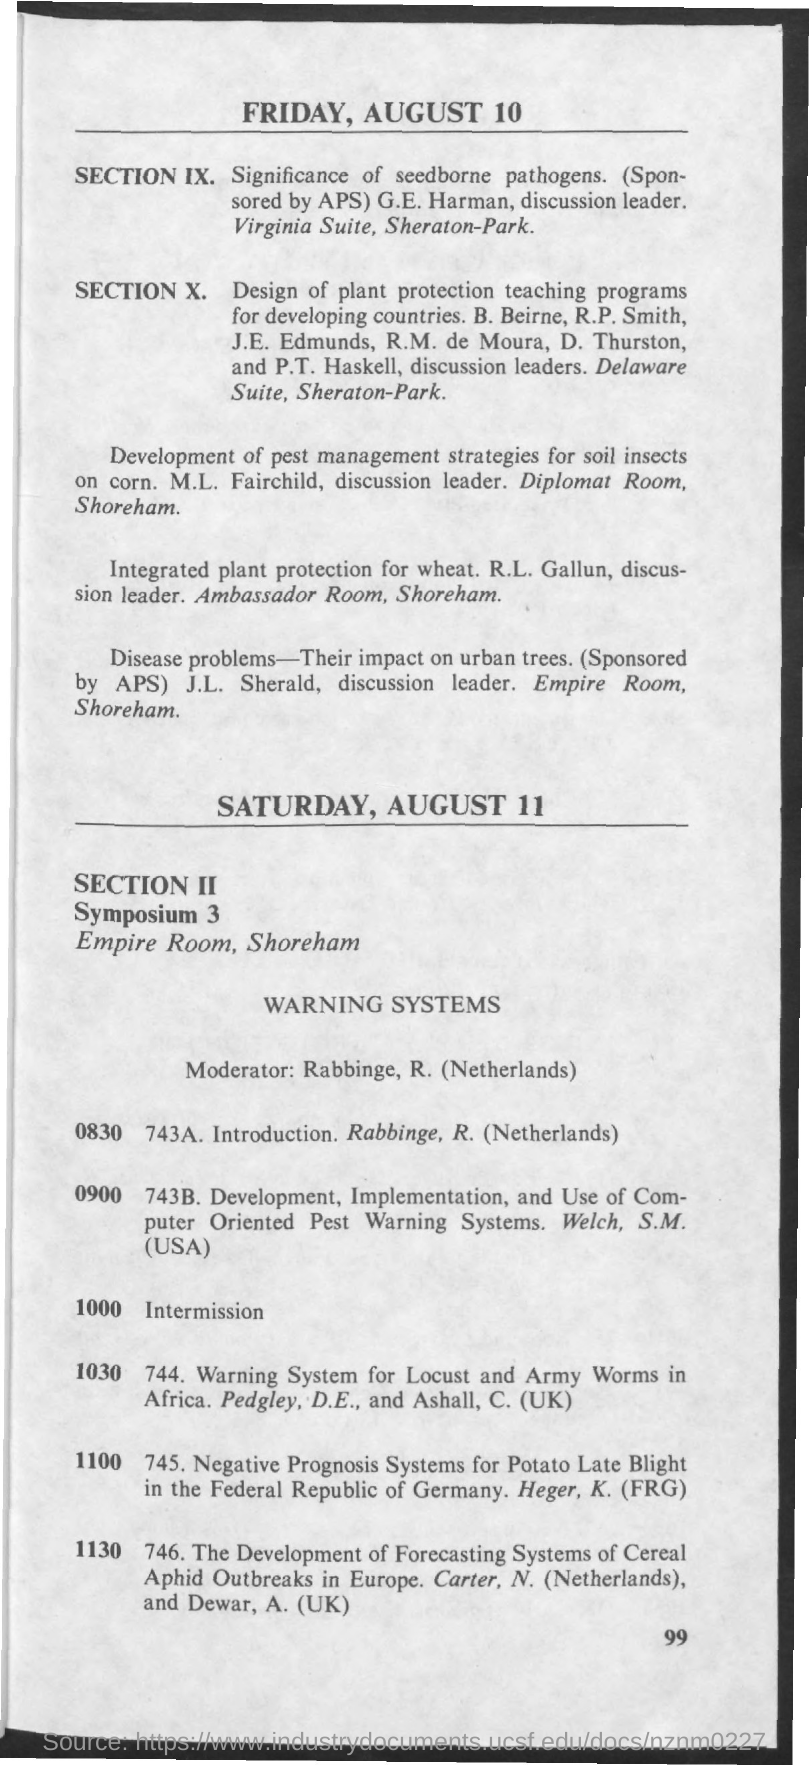What is the date mentioned in the given page ?
Your response must be concise. Friday , august 10. What is the name of the room for symposium 3 ?
Offer a terse response. Empire room. 